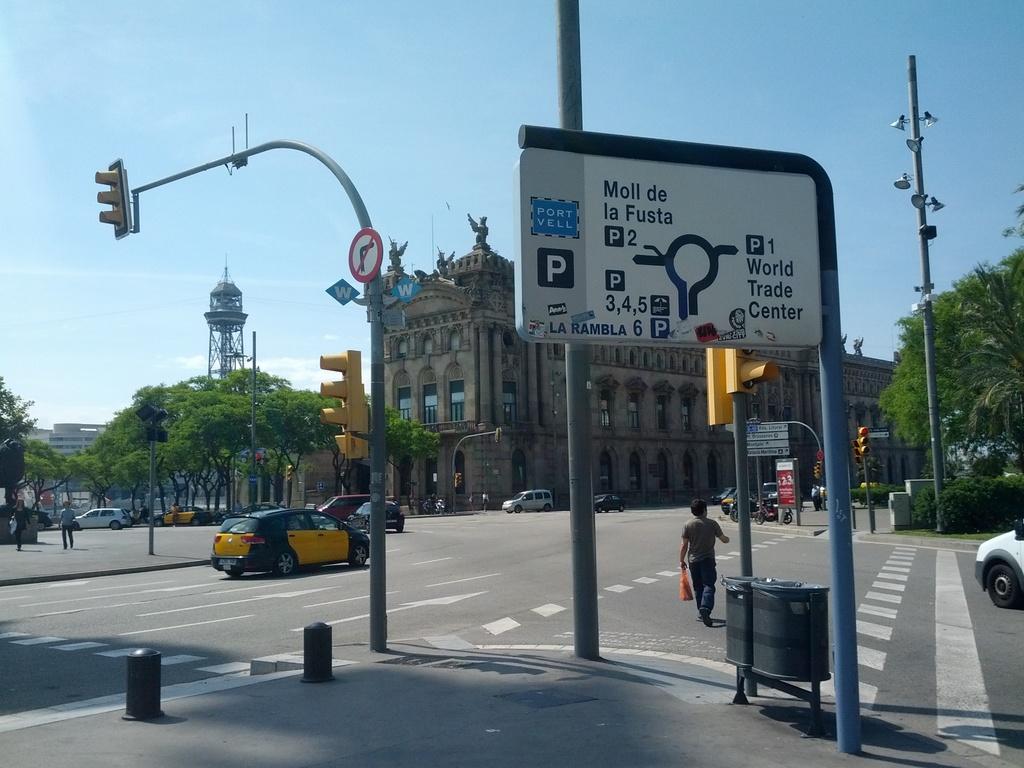What trade center is nearby?
Make the answer very short. World trade center. What direction is on the street post?
Offer a terse response. Right. 